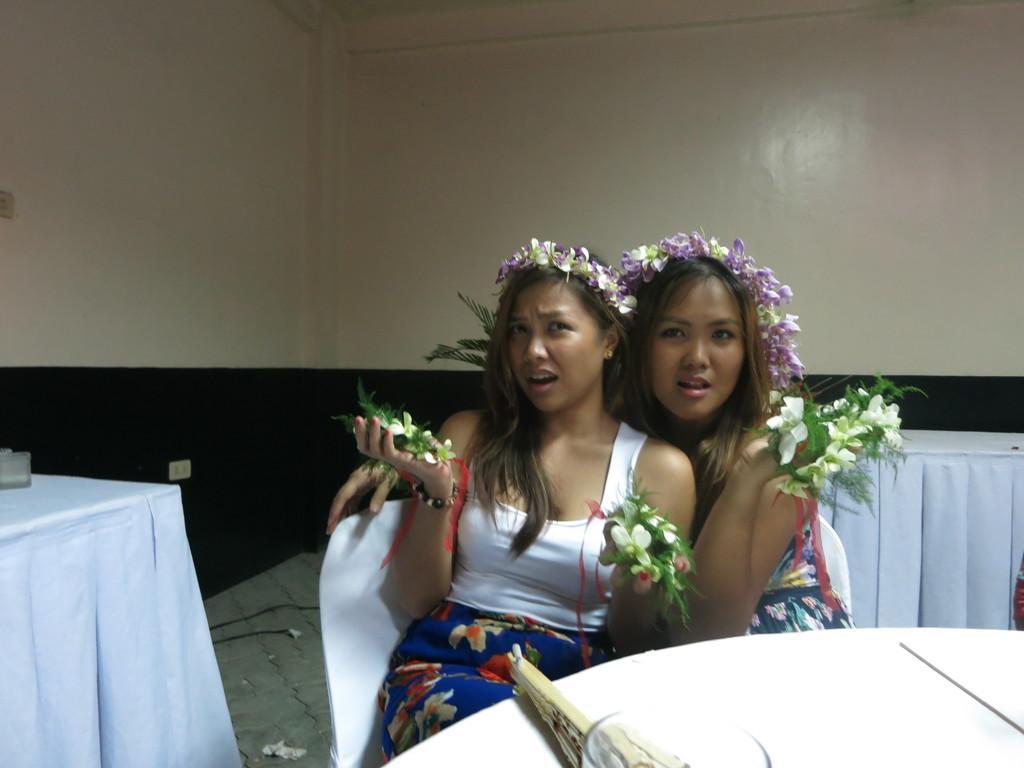Describe this image in one or two sentences. In this picture we can see 2 women wearing a headgear and holding flowers in their hands. There are sitting on a chair near a table. 